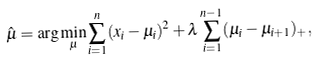<formula> <loc_0><loc_0><loc_500><loc_500>\hat { \mu } = \arg \min _ { \mu } \sum _ { i = 1 } ^ { n } ( x _ { i } - \mu _ { i } ) ^ { 2 } + \lambda \sum _ { i = 1 } ^ { n - 1 } ( \mu _ { i } - \mu _ { i + 1 } ) _ { + } ,</formula> 